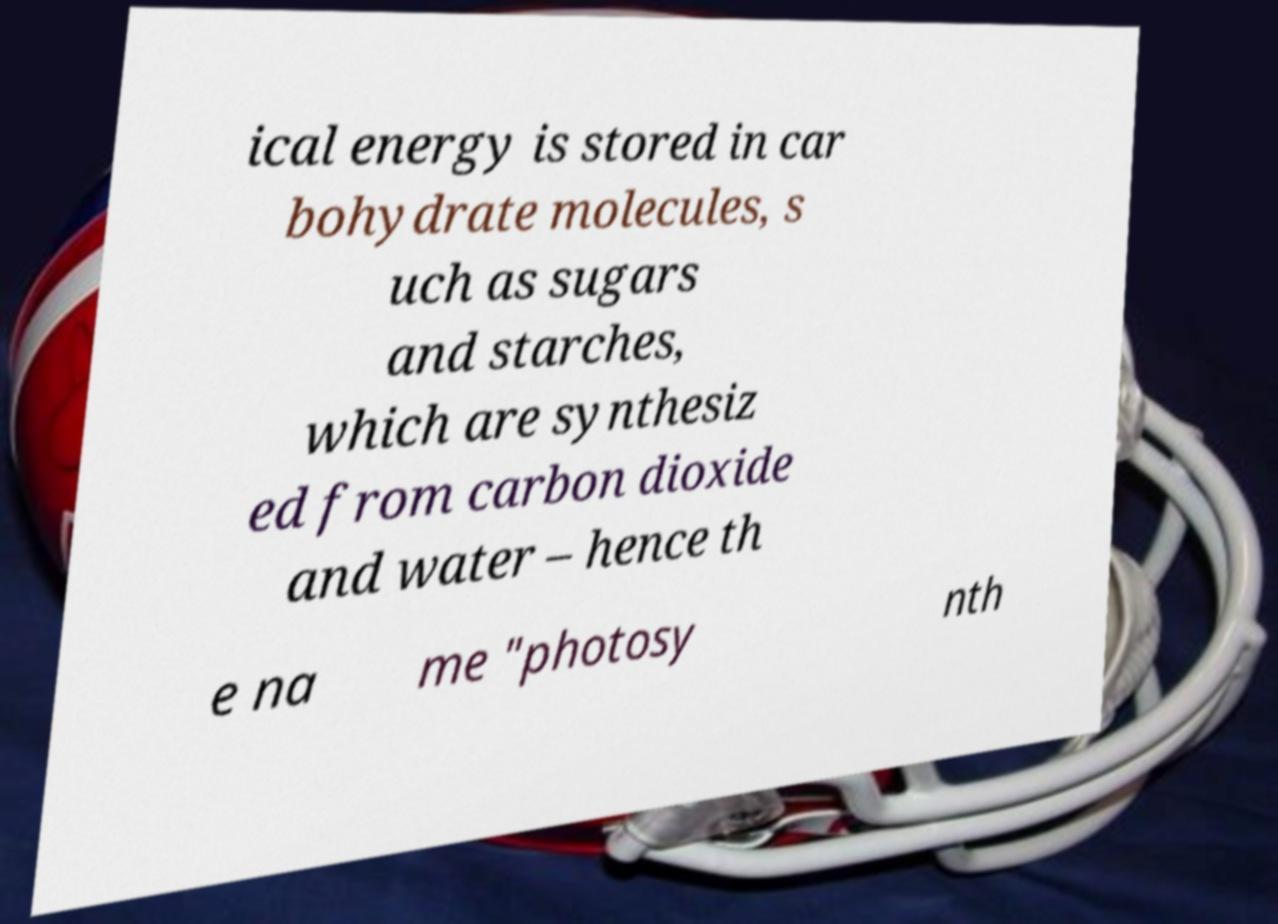Can you accurately transcribe the text from the provided image for me? ical energy is stored in car bohydrate molecules, s uch as sugars and starches, which are synthesiz ed from carbon dioxide and water – hence th e na me "photosy nth 